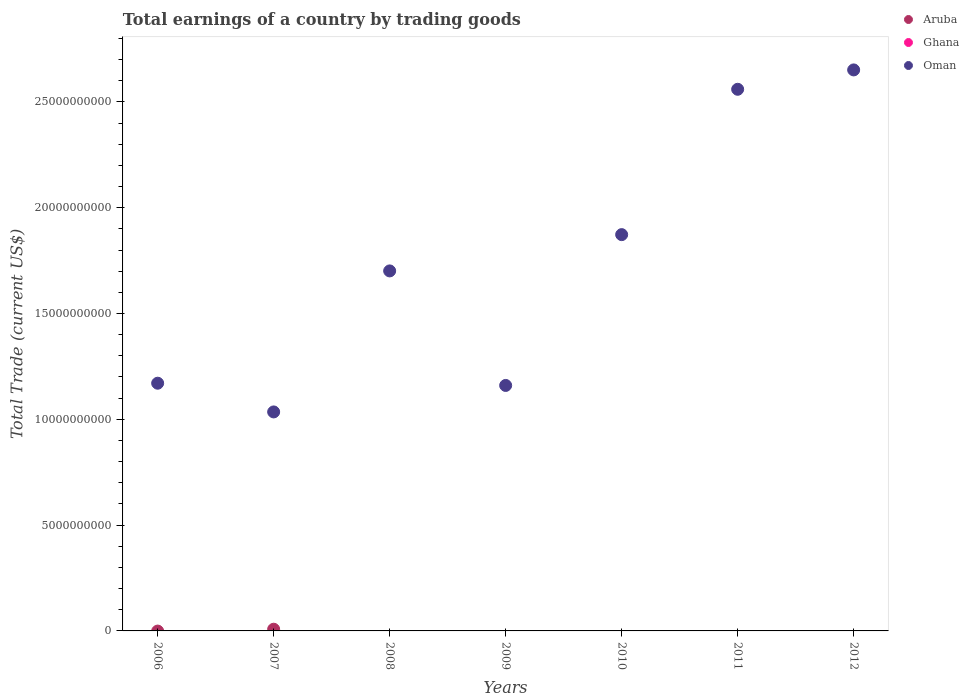What is the total earnings in Ghana in 2006?
Keep it short and to the point. 0. Across all years, what is the maximum total earnings in Aruba?
Provide a succinct answer. 8.06e+07. Across all years, what is the minimum total earnings in Ghana?
Ensure brevity in your answer.  0. In which year was the total earnings in Oman maximum?
Keep it short and to the point. 2012. What is the total total earnings in Oman in the graph?
Your response must be concise. 1.21e+11. What is the difference between the total earnings in Oman in 2009 and that in 2010?
Your response must be concise. -7.13e+09. What is the difference between the total earnings in Aruba in 2006 and the total earnings in Oman in 2007?
Your answer should be compact. -1.03e+1. Is the total earnings in Oman in 2006 less than that in 2012?
Your response must be concise. Yes. What is the difference between the highest and the second highest total earnings in Oman?
Keep it short and to the point. 9.15e+08. What is the difference between the highest and the lowest total earnings in Aruba?
Your answer should be compact. 8.06e+07. In how many years, is the total earnings in Ghana greater than the average total earnings in Ghana taken over all years?
Keep it short and to the point. 0. Is the sum of the total earnings in Oman in 2007 and 2012 greater than the maximum total earnings in Ghana across all years?
Offer a very short reply. Yes. Is it the case that in every year, the sum of the total earnings in Oman and total earnings in Aruba  is greater than the total earnings in Ghana?
Keep it short and to the point. Yes. Does the total earnings in Oman monotonically increase over the years?
Offer a terse response. No. Is the total earnings in Aruba strictly less than the total earnings in Ghana over the years?
Offer a terse response. No. How many dotlines are there?
Provide a short and direct response. 2. How many years are there in the graph?
Give a very brief answer. 7. What is the difference between two consecutive major ticks on the Y-axis?
Give a very brief answer. 5.00e+09. Does the graph contain grids?
Your answer should be compact. No. How many legend labels are there?
Provide a short and direct response. 3. What is the title of the graph?
Offer a terse response. Total earnings of a country by trading goods. Does "Least developed countries" appear as one of the legend labels in the graph?
Offer a very short reply. No. What is the label or title of the X-axis?
Your answer should be very brief. Years. What is the label or title of the Y-axis?
Your response must be concise. Total Trade (current US$). What is the Total Trade (current US$) in Aruba in 2006?
Provide a short and direct response. 0. What is the Total Trade (current US$) of Ghana in 2006?
Give a very brief answer. 0. What is the Total Trade (current US$) of Oman in 2006?
Keep it short and to the point. 1.17e+1. What is the Total Trade (current US$) of Aruba in 2007?
Your answer should be very brief. 8.06e+07. What is the Total Trade (current US$) of Ghana in 2007?
Ensure brevity in your answer.  0. What is the Total Trade (current US$) in Oman in 2007?
Give a very brief answer. 1.03e+1. What is the Total Trade (current US$) in Ghana in 2008?
Give a very brief answer. 0. What is the Total Trade (current US$) in Oman in 2008?
Make the answer very short. 1.70e+1. What is the Total Trade (current US$) in Aruba in 2009?
Provide a short and direct response. 0. What is the Total Trade (current US$) in Ghana in 2009?
Your response must be concise. 0. What is the Total Trade (current US$) of Oman in 2009?
Your answer should be compact. 1.16e+1. What is the Total Trade (current US$) in Ghana in 2010?
Your response must be concise. 0. What is the Total Trade (current US$) in Oman in 2010?
Your response must be concise. 1.87e+1. What is the Total Trade (current US$) of Aruba in 2011?
Offer a terse response. 0. What is the Total Trade (current US$) of Ghana in 2011?
Keep it short and to the point. 0. What is the Total Trade (current US$) in Oman in 2011?
Provide a succinct answer. 2.56e+1. What is the Total Trade (current US$) in Aruba in 2012?
Offer a very short reply. 0. What is the Total Trade (current US$) of Ghana in 2012?
Make the answer very short. 0. What is the Total Trade (current US$) in Oman in 2012?
Make the answer very short. 2.65e+1. Across all years, what is the maximum Total Trade (current US$) of Aruba?
Your answer should be very brief. 8.06e+07. Across all years, what is the maximum Total Trade (current US$) in Oman?
Offer a terse response. 2.65e+1. Across all years, what is the minimum Total Trade (current US$) of Aruba?
Provide a succinct answer. 0. Across all years, what is the minimum Total Trade (current US$) in Oman?
Your response must be concise. 1.03e+1. What is the total Total Trade (current US$) of Aruba in the graph?
Offer a terse response. 8.06e+07. What is the total Total Trade (current US$) of Ghana in the graph?
Your answer should be compact. 0. What is the total Total Trade (current US$) of Oman in the graph?
Ensure brevity in your answer.  1.21e+11. What is the difference between the Total Trade (current US$) of Oman in 2006 and that in 2007?
Make the answer very short. 1.36e+09. What is the difference between the Total Trade (current US$) in Oman in 2006 and that in 2008?
Keep it short and to the point. -5.31e+09. What is the difference between the Total Trade (current US$) in Oman in 2006 and that in 2009?
Your response must be concise. 1.06e+08. What is the difference between the Total Trade (current US$) of Oman in 2006 and that in 2010?
Ensure brevity in your answer.  -7.02e+09. What is the difference between the Total Trade (current US$) in Oman in 2006 and that in 2011?
Your answer should be very brief. -1.39e+1. What is the difference between the Total Trade (current US$) of Oman in 2006 and that in 2012?
Provide a short and direct response. -1.48e+1. What is the difference between the Total Trade (current US$) of Oman in 2007 and that in 2008?
Your answer should be very brief. -6.66e+09. What is the difference between the Total Trade (current US$) in Oman in 2007 and that in 2009?
Provide a short and direct response. -1.25e+09. What is the difference between the Total Trade (current US$) of Oman in 2007 and that in 2010?
Your answer should be compact. -8.38e+09. What is the difference between the Total Trade (current US$) in Oman in 2007 and that in 2011?
Give a very brief answer. -1.52e+1. What is the difference between the Total Trade (current US$) of Oman in 2007 and that in 2012?
Ensure brevity in your answer.  -1.62e+1. What is the difference between the Total Trade (current US$) of Oman in 2008 and that in 2009?
Keep it short and to the point. 5.41e+09. What is the difference between the Total Trade (current US$) in Oman in 2008 and that in 2010?
Keep it short and to the point. -1.71e+09. What is the difference between the Total Trade (current US$) in Oman in 2008 and that in 2011?
Provide a succinct answer. -8.58e+09. What is the difference between the Total Trade (current US$) in Oman in 2008 and that in 2012?
Give a very brief answer. -9.50e+09. What is the difference between the Total Trade (current US$) of Oman in 2009 and that in 2010?
Ensure brevity in your answer.  -7.13e+09. What is the difference between the Total Trade (current US$) of Oman in 2009 and that in 2011?
Give a very brief answer. -1.40e+1. What is the difference between the Total Trade (current US$) in Oman in 2009 and that in 2012?
Your answer should be very brief. -1.49e+1. What is the difference between the Total Trade (current US$) in Oman in 2010 and that in 2011?
Offer a very short reply. -6.87e+09. What is the difference between the Total Trade (current US$) in Oman in 2010 and that in 2012?
Make the answer very short. -7.78e+09. What is the difference between the Total Trade (current US$) in Oman in 2011 and that in 2012?
Your answer should be compact. -9.15e+08. What is the difference between the Total Trade (current US$) of Aruba in 2007 and the Total Trade (current US$) of Oman in 2008?
Give a very brief answer. -1.69e+1. What is the difference between the Total Trade (current US$) of Aruba in 2007 and the Total Trade (current US$) of Oman in 2009?
Provide a short and direct response. -1.15e+1. What is the difference between the Total Trade (current US$) of Aruba in 2007 and the Total Trade (current US$) of Oman in 2010?
Give a very brief answer. -1.86e+1. What is the difference between the Total Trade (current US$) in Aruba in 2007 and the Total Trade (current US$) in Oman in 2011?
Ensure brevity in your answer.  -2.55e+1. What is the difference between the Total Trade (current US$) of Aruba in 2007 and the Total Trade (current US$) of Oman in 2012?
Your response must be concise. -2.64e+1. What is the average Total Trade (current US$) of Aruba per year?
Your response must be concise. 1.15e+07. What is the average Total Trade (current US$) in Oman per year?
Give a very brief answer. 1.74e+1. In the year 2007, what is the difference between the Total Trade (current US$) in Aruba and Total Trade (current US$) in Oman?
Provide a succinct answer. -1.03e+1. What is the ratio of the Total Trade (current US$) of Oman in 2006 to that in 2007?
Offer a terse response. 1.13. What is the ratio of the Total Trade (current US$) of Oman in 2006 to that in 2008?
Keep it short and to the point. 0.69. What is the ratio of the Total Trade (current US$) of Oman in 2006 to that in 2009?
Offer a very short reply. 1.01. What is the ratio of the Total Trade (current US$) of Oman in 2006 to that in 2010?
Offer a very short reply. 0.63. What is the ratio of the Total Trade (current US$) in Oman in 2006 to that in 2011?
Your answer should be very brief. 0.46. What is the ratio of the Total Trade (current US$) in Oman in 2006 to that in 2012?
Make the answer very short. 0.44. What is the ratio of the Total Trade (current US$) in Oman in 2007 to that in 2008?
Keep it short and to the point. 0.61. What is the ratio of the Total Trade (current US$) of Oman in 2007 to that in 2009?
Offer a very short reply. 0.89. What is the ratio of the Total Trade (current US$) of Oman in 2007 to that in 2010?
Your answer should be compact. 0.55. What is the ratio of the Total Trade (current US$) of Oman in 2007 to that in 2011?
Make the answer very short. 0.4. What is the ratio of the Total Trade (current US$) of Oman in 2007 to that in 2012?
Provide a short and direct response. 0.39. What is the ratio of the Total Trade (current US$) in Oman in 2008 to that in 2009?
Make the answer very short. 1.47. What is the ratio of the Total Trade (current US$) in Oman in 2008 to that in 2010?
Your answer should be very brief. 0.91. What is the ratio of the Total Trade (current US$) in Oman in 2008 to that in 2011?
Your answer should be very brief. 0.66. What is the ratio of the Total Trade (current US$) of Oman in 2008 to that in 2012?
Ensure brevity in your answer.  0.64. What is the ratio of the Total Trade (current US$) in Oman in 2009 to that in 2010?
Ensure brevity in your answer.  0.62. What is the ratio of the Total Trade (current US$) in Oman in 2009 to that in 2011?
Your answer should be very brief. 0.45. What is the ratio of the Total Trade (current US$) of Oman in 2009 to that in 2012?
Provide a short and direct response. 0.44. What is the ratio of the Total Trade (current US$) in Oman in 2010 to that in 2011?
Ensure brevity in your answer.  0.73. What is the ratio of the Total Trade (current US$) in Oman in 2010 to that in 2012?
Make the answer very short. 0.71. What is the ratio of the Total Trade (current US$) in Oman in 2011 to that in 2012?
Give a very brief answer. 0.97. What is the difference between the highest and the second highest Total Trade (current US$) in Oman?
Keep it short and to the point. 9.15e+08. What is the difference between the highest and the lowest Total Trade (current US$) of Aruba?
Provide a succinct answer. 8.06e+07. What is the difference between the highest and the lowest Total Trade (current US$) of Oman?
Make the answer very short. 1.62e+1. 